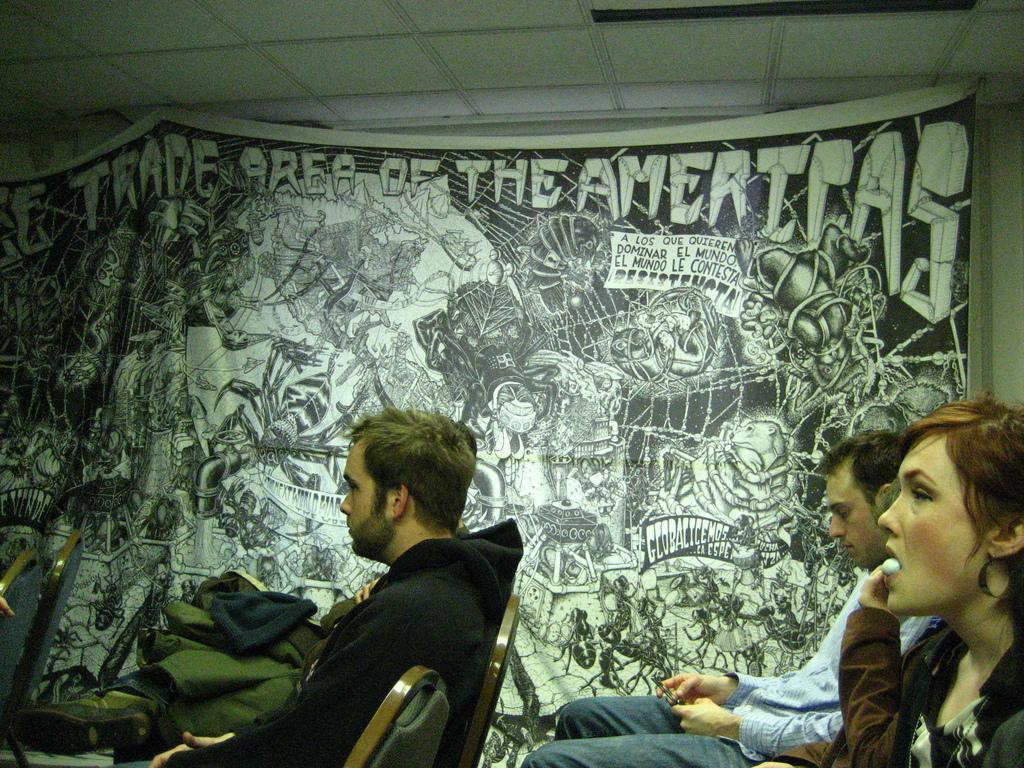What are the people in the image doing? The people in the image are sitting on chairs. What can be seen on the wall in the image? There is a banner with images and text on the wall. What type of glue is being used to attach the banner to the wall in the image? There is no glue visible in the image, and the method of attaching the banner to the wall is not mentioned. 